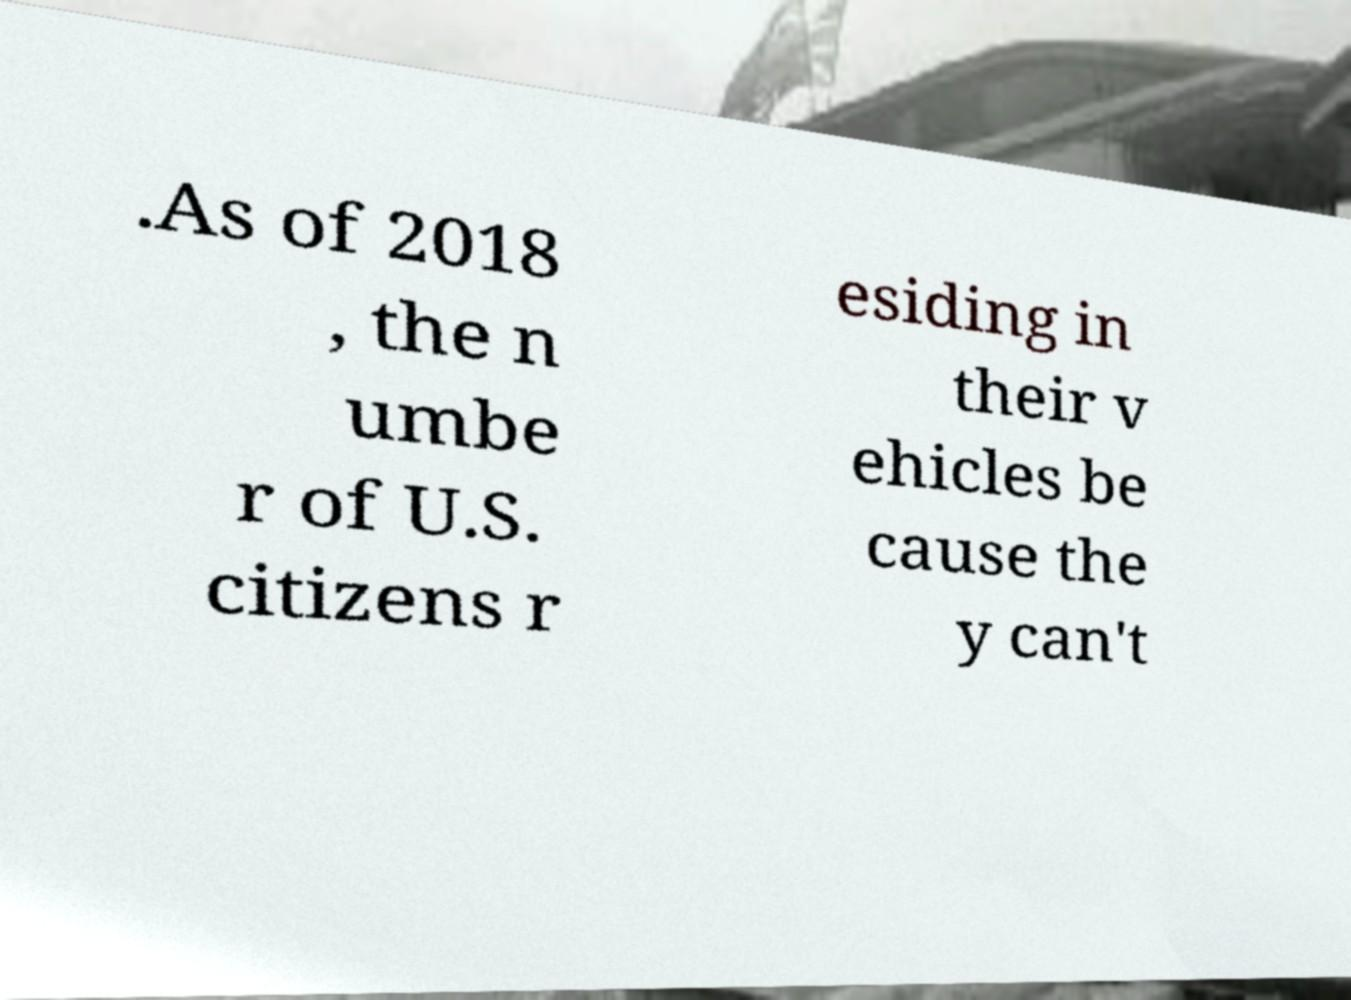I need the written content from this picture converted into text. Can you do that? .As of 2018 , the n umbe r of U.S. citizens r esiding in their v ehicles be cause the y can't 